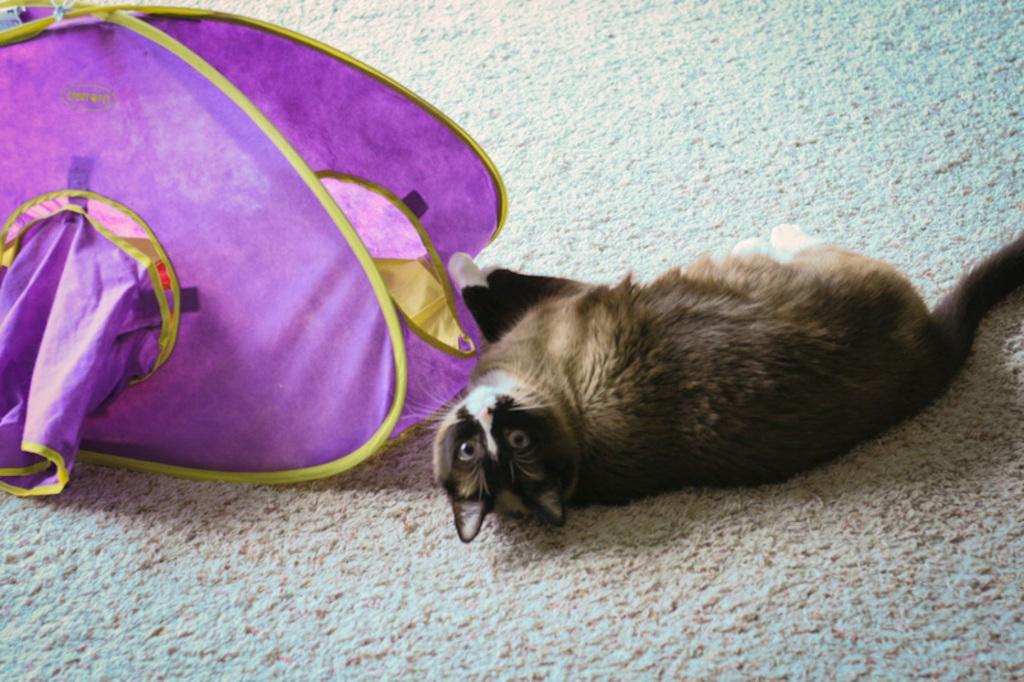Could you give a brief overview of what you see in this image? In this image there is a cat lay on the mat. Beside the cat there is a cat house. 